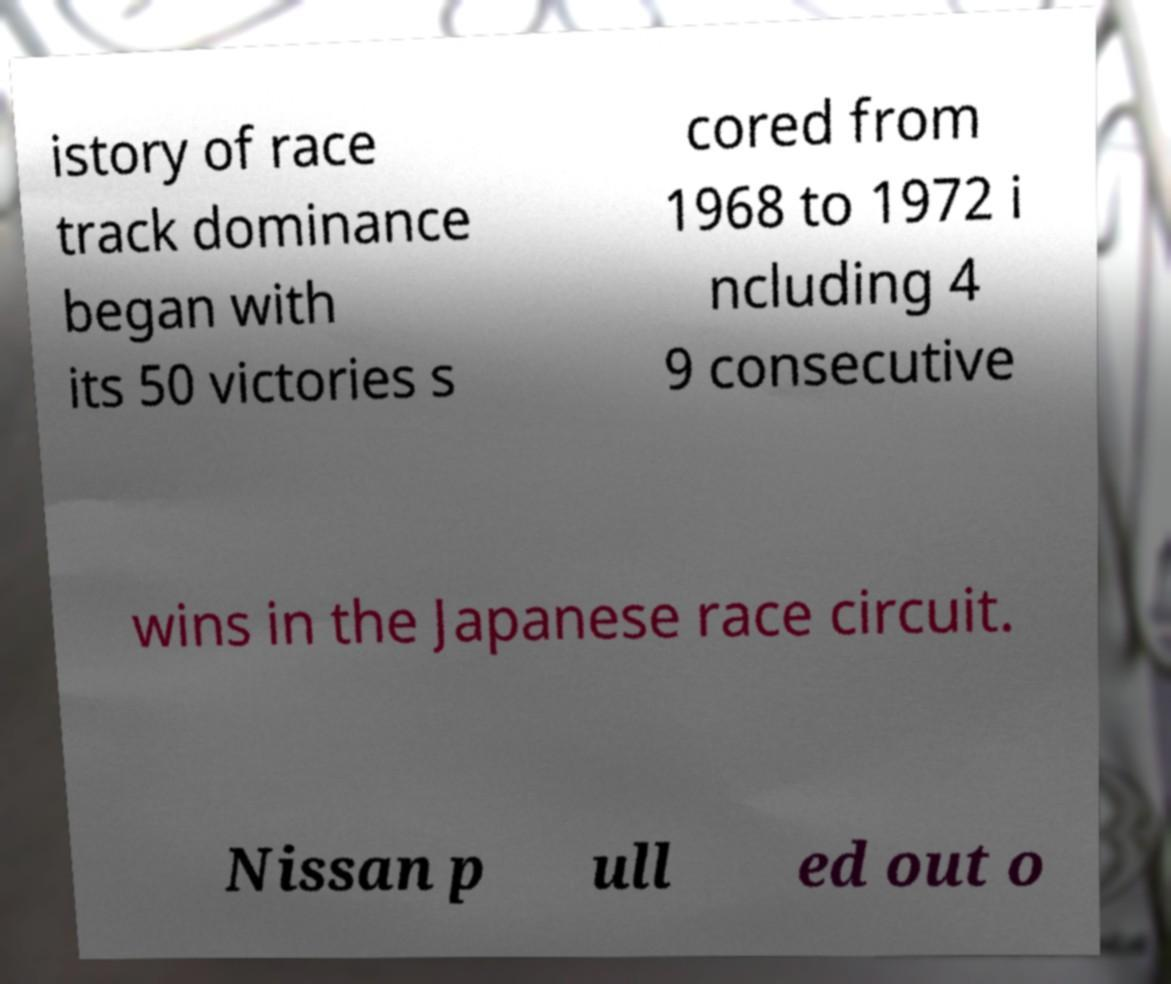I need the written content from this picture converted into text. Can you do that? istory of race track dominance began with its 50 victories s cored from 1968 to 1972 i ncluding 4 9 consecutive wins in the Japanese race circuit. Nissan p ull ed out o 